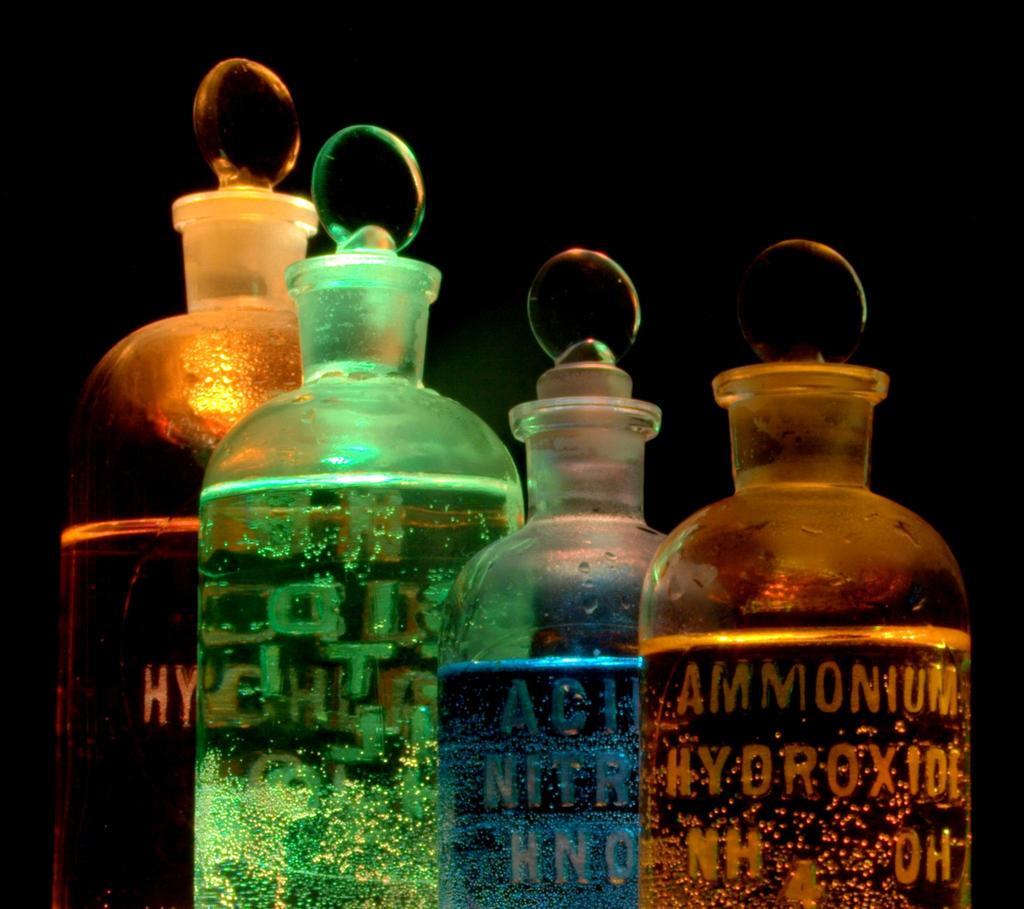What's the first word on the item on the far right?
Keep it short and to the point. Ammonium. What is the second word on the bottle on the right?
Your response must be concise. Hydroxide. 